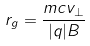Convert formula to latex. <formula><loc_0><loc_0><loc_500><loc_500>r _ { g } = \frac { m c v _ { \perp } } { | q | B }</formula> 